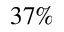<formula> <loc_0><loc_0><loc_500><loc_500>3 7 \%</formula> 